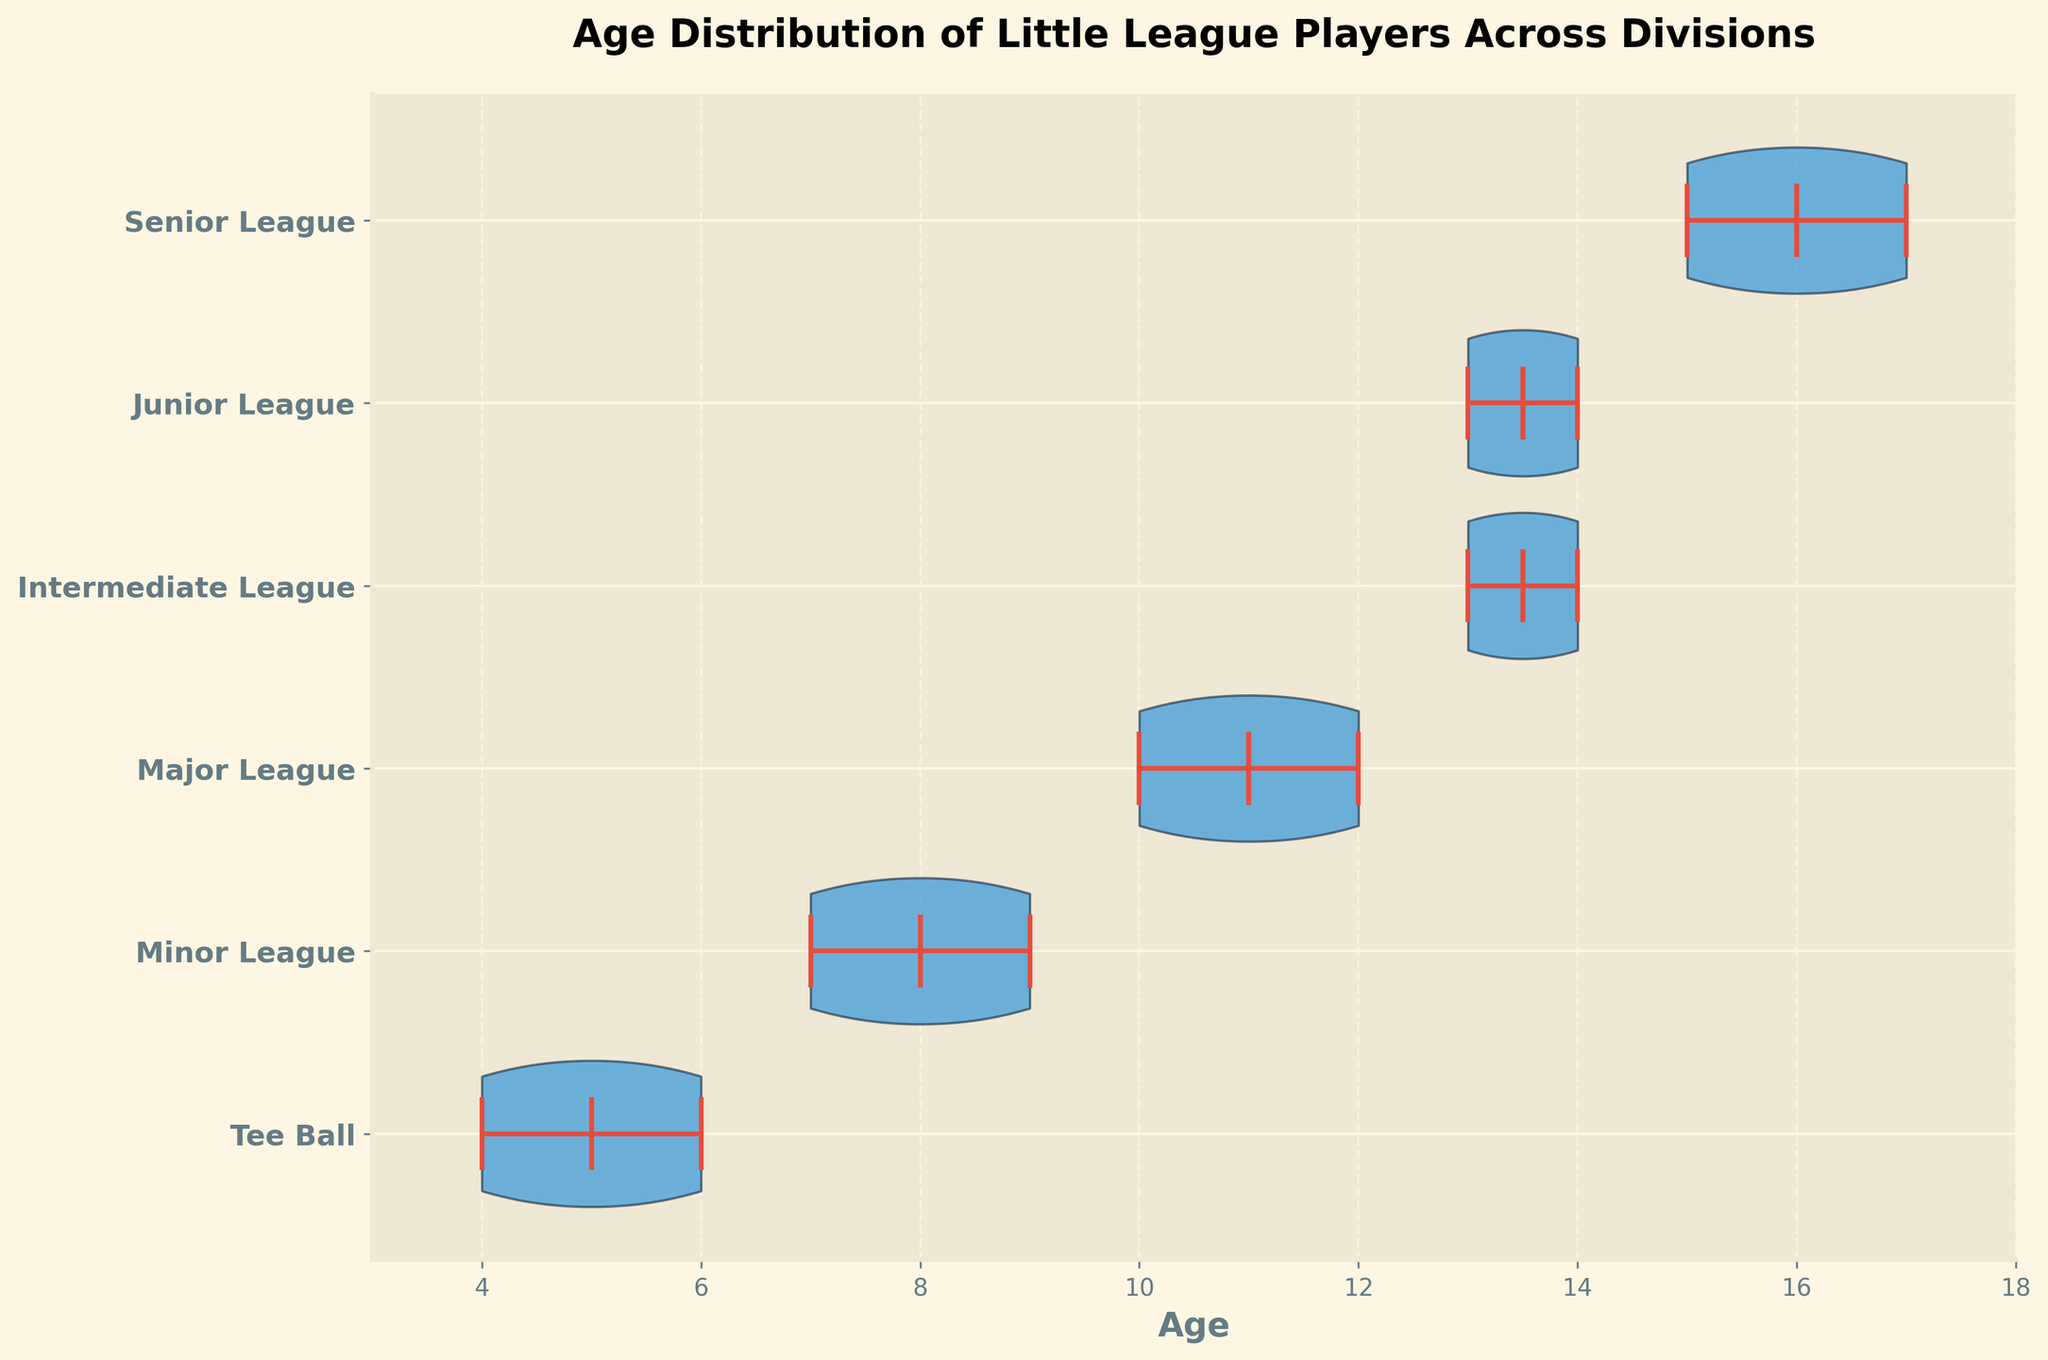What is the title of the figure? The title is the most descriptive large text at the top of the chart.
Answer: Age Distribution of Little League Players Across Divisions How many divisions are represented in the chart? Count the unique division labels on the y-axis.
Answer: 6 Which division shows the highest median age? Identify the horizontal line inside the violin shape that's at the highest age value.
Answer: Senior League How does the age range of Major League compare to that of Intermediate League? Check the spread of the violin shapes. Major League stretches from 10 to 12, whereas Intermediate League stretches from 13 to 14.
Answer: Major League: 10-12, Intermediate League: 13-14 Which division has the youngest median age? Look for the lowest horizontal median line inside the violin shapes.
Answer: Tee Ball Between Tee Ball and Minor League, which one has a wider age distribution? Observe which violin shape is spread over a larger age range.
Answer: Minor League What is the mean age of players in Junior League? Identify the symbol for the mean (usually a dot) within the Junior League violin shape. It lies at approximately 13.5.
Answer: 13.5 Are there any divisions where the ages do not overlap at all? Compare the ranges of each division's violin shape.
Answer: Yes, Senior League (15-17) and all other divisions Which division has the smallest variation in age? Determine which violin shape is the narrowest.
Answer: Intermediate League What is the maximum age range for any division in the chart? Check the difference between the extremes for each division. The widest range is in the Senior League (15-17).
Answer: 2 